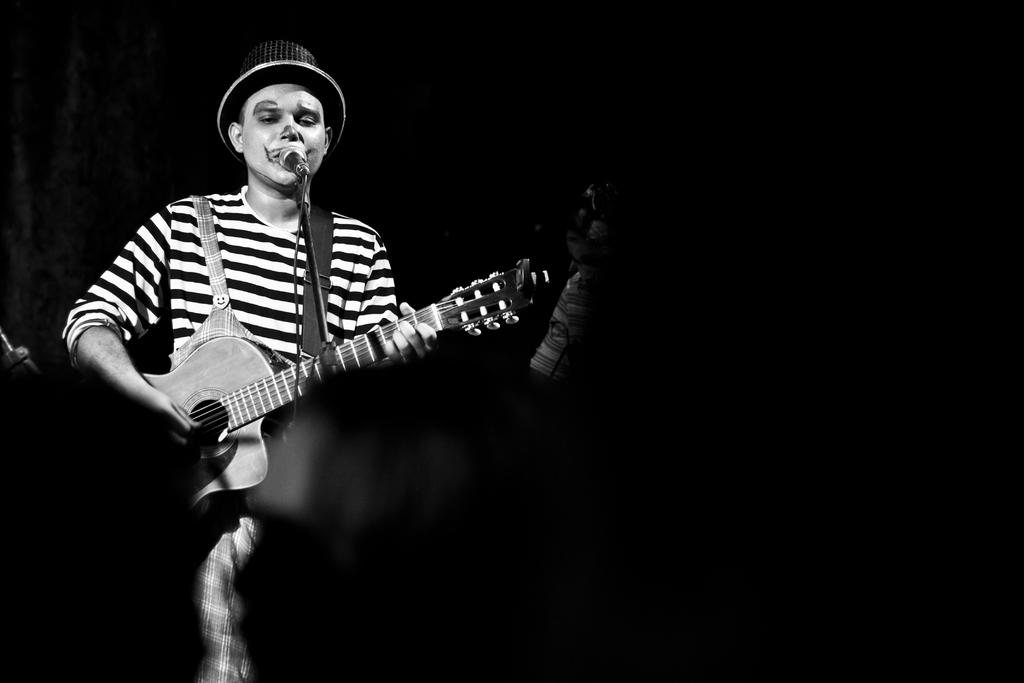What is the main subject of the image? The main subject of the image is a musician. What is the musician doing in the image? The musician is performing in front of a microphone. What instrument is the musician playing? The musician is holding a guitar and playing it. What type of noise can be heard coming from the guitar in the image? There is no sound present in the image, so it is not possible to determine what type of noise might be heard from the guitar. 